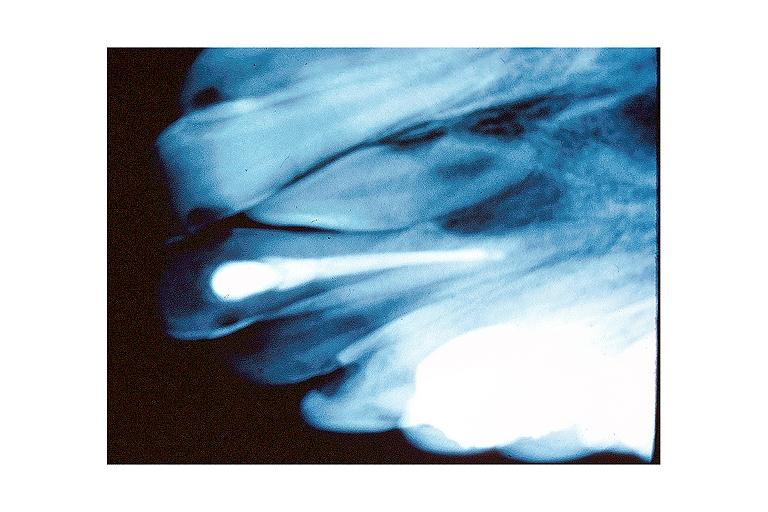what does this image show?
Answer the question using a single word or phrase. Mesiodens 